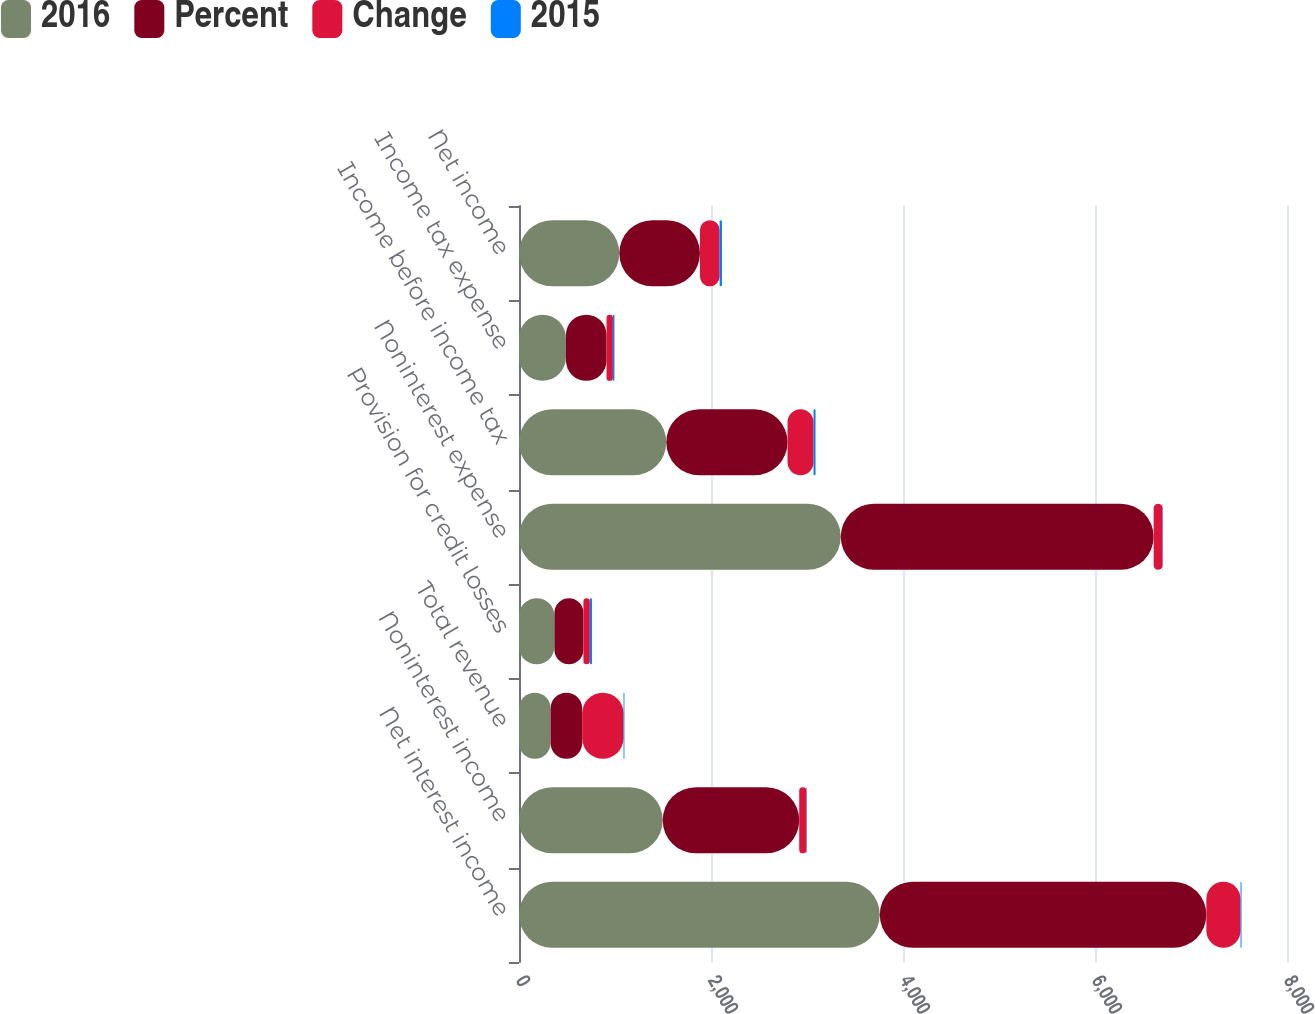<chart> <loc_0><loc_0><loc_500><loc_500><stacked_bar_chart><ecel><fcel>Net interest income<fcel>Noninterest income<fcel>Total revenue<fcel>Provision for credit losses<fcel>Noninterest expense<fcel>Income before income tax<fcel>Income tax expense<fcel>Net income<nl><fcel>2016<fcel>3758<fcel>1497<fcel>329<fcel>369<fcel>3352<fcel>1534<fcel>489<fcel>1045<nl><fcel>Percent<fcel>3402<fcel>1422<fcel>329<fcel>302<fcel>3259<fcel>1263<fcel>423<fcel>840<nl><fcel>Change<fcel>356<fcel>75<fcel>431<fcel>67<fcel>93<fcel>271<fcel>66<fcel>205<nl><fcel>2015<fcel>10<fcel>5<fcel>9<fcel>22<fcel>3<fcel>21<fcel>16<fcel>24<nl></chart> 